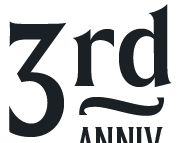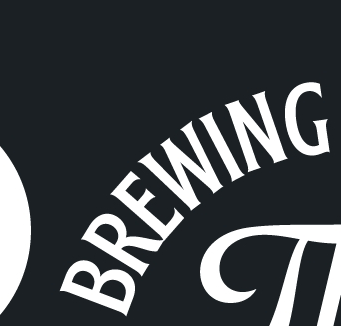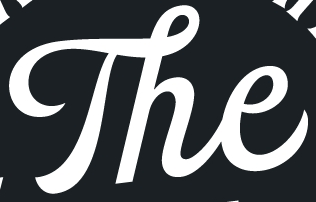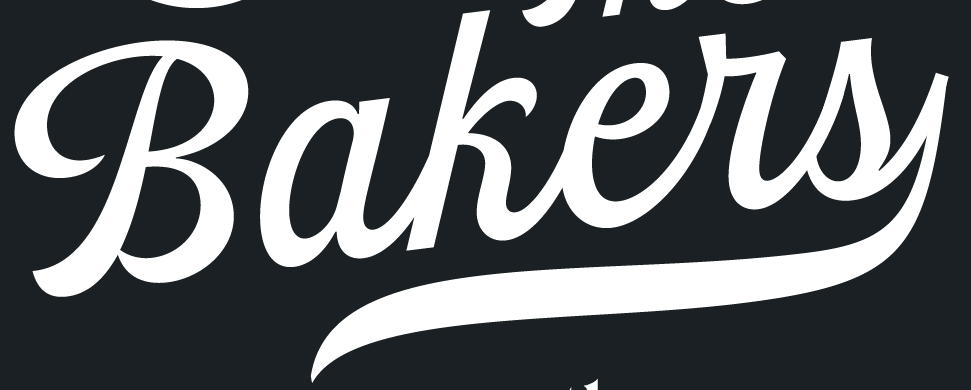What text appears in these images from left to right, separated by a semicolon? 3rd; BREWING; The; Bakers 